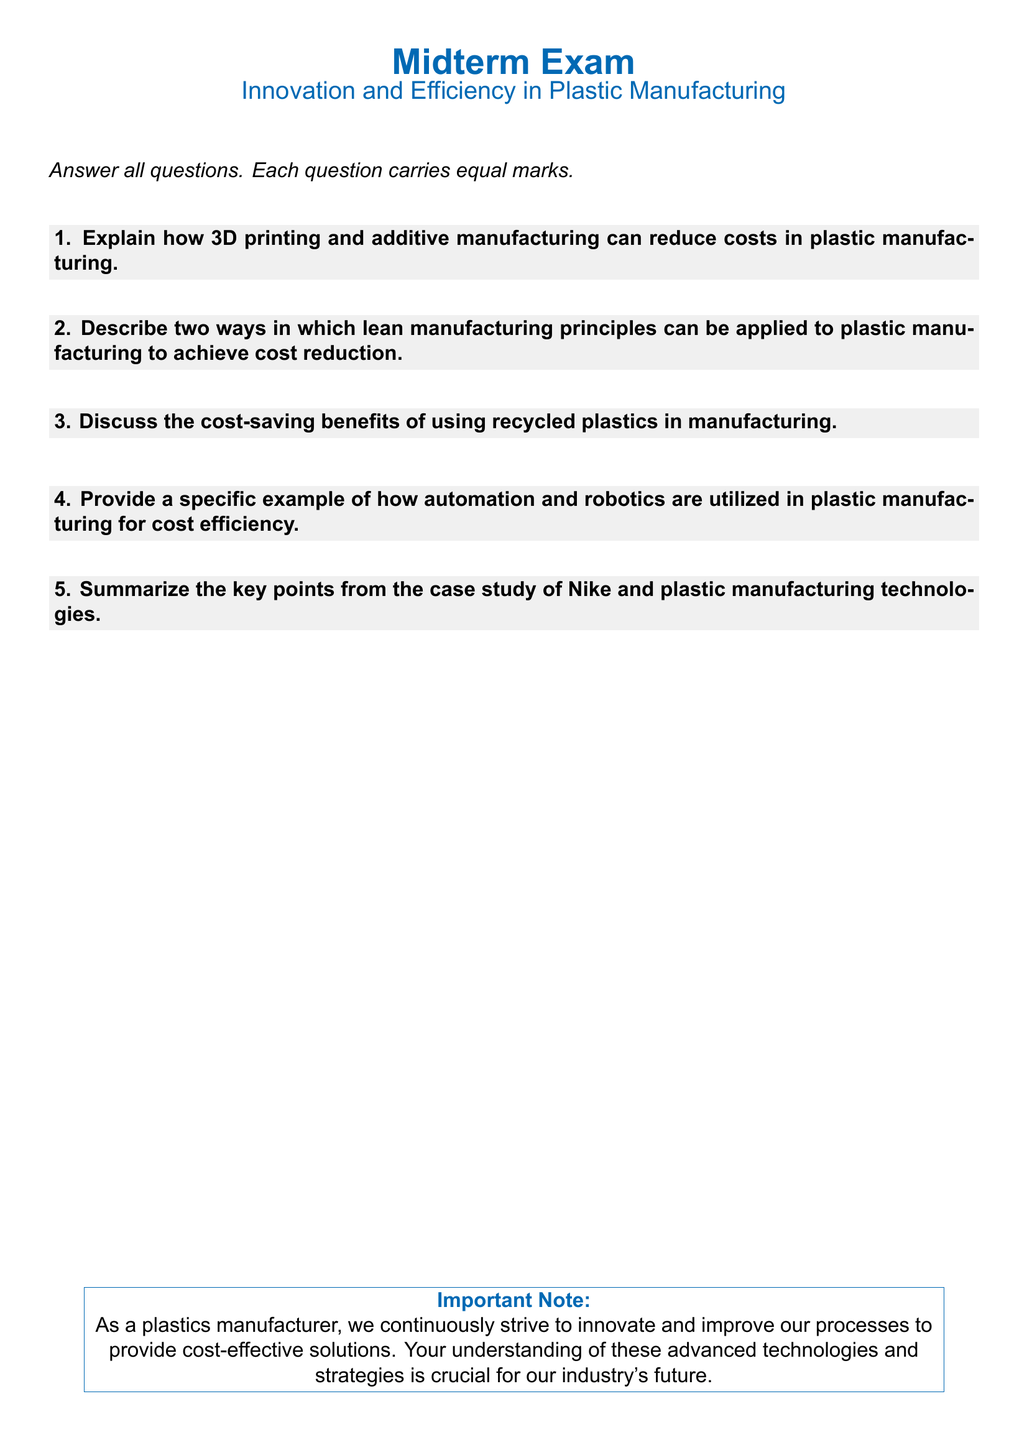What is the title of the exam? The title is provided at the top of the document, which states the topic of the examination.
Answer: Midterm Exam What is the main focus of the midterm exam? The main focus of the exam is explicitly stated in the subtitle below the title.
Answer: Innovation and Efficiency in Plastic Manufacturing How many exam questions are there? The number of questions is indicated by the content of the document.
Answer: Five What color is used for the section titles? The specific color for section titles is defined in the styling section of the document.
Answer: Plastic blue What is one application of lean manufacturing principles mentioned? The second exam question asks for two ways lean manufacturing can be applied, indicating multiple applications are expected.
Answer: Two ways Which company is mentioned in the case study? The specific company referenced in the case study is stated directly in the corresponding exam question.
Answer: Nike What is the purpose of including the important note at the end? The note aims to emphasize the significance of understanding advanced technologies and strategies in the industry context.
Answer: To emphasize continuous innovation and cost-effective solutions 